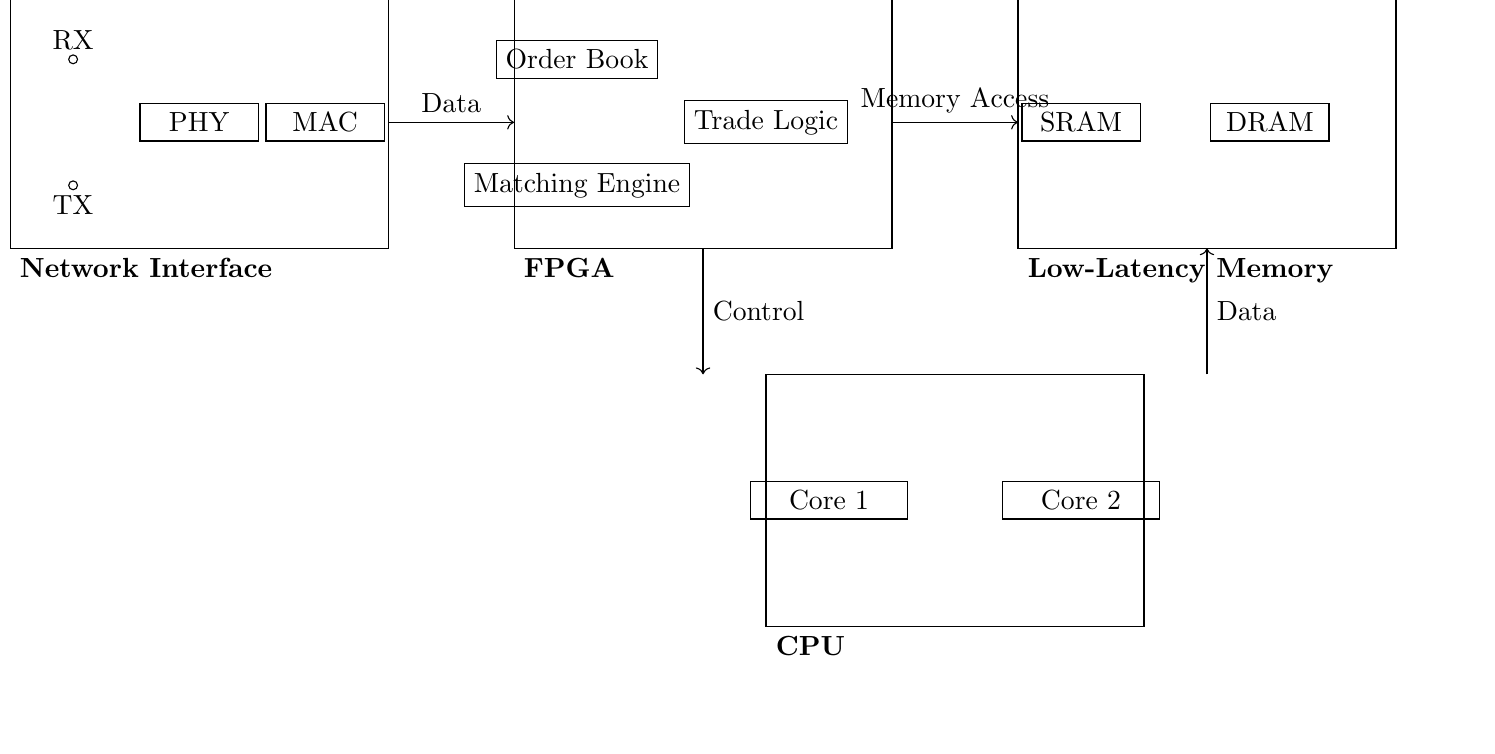What is the main function of the FPGA? The FPGA houses key components such as the order book, matching engine, and trade logic, which are essential for executing trading algorithms.
Answer: Execute trading algorithms What type of memory is used in this circuit? The circuit incorporates SRAM and DRAM, which are low-latency memory types suitable for handling frequent data transfers in high-frequency trading.
Answer: SRAM and DRAM How many cores does the CPU have? The CPU contains two cores as indicated by the labeled components, Core 1 and Core 2, located within its section of the circuit.
Answer: Two cores What is the role of the PHY component? The PHY component acts as a physical layer interface, facilitating the conversion of electrical signals for data transmission and reception alongside the RX and TX units.
Answer: Data transmission and reception What type of interface is represented by the TX and RX nodes? The TX (transmit) and RX (receive) nodes represent the input/output interface, essential for data communication in the network interface of the circuit.
Answer: Input/output interface Which components directly interact with the network interface? The components that interact directly with the network interface include the FPGA and the low-latency memory, emphasizing the data flow required for high-speed trading operations.
Answer: FPGA and low-latency memory 